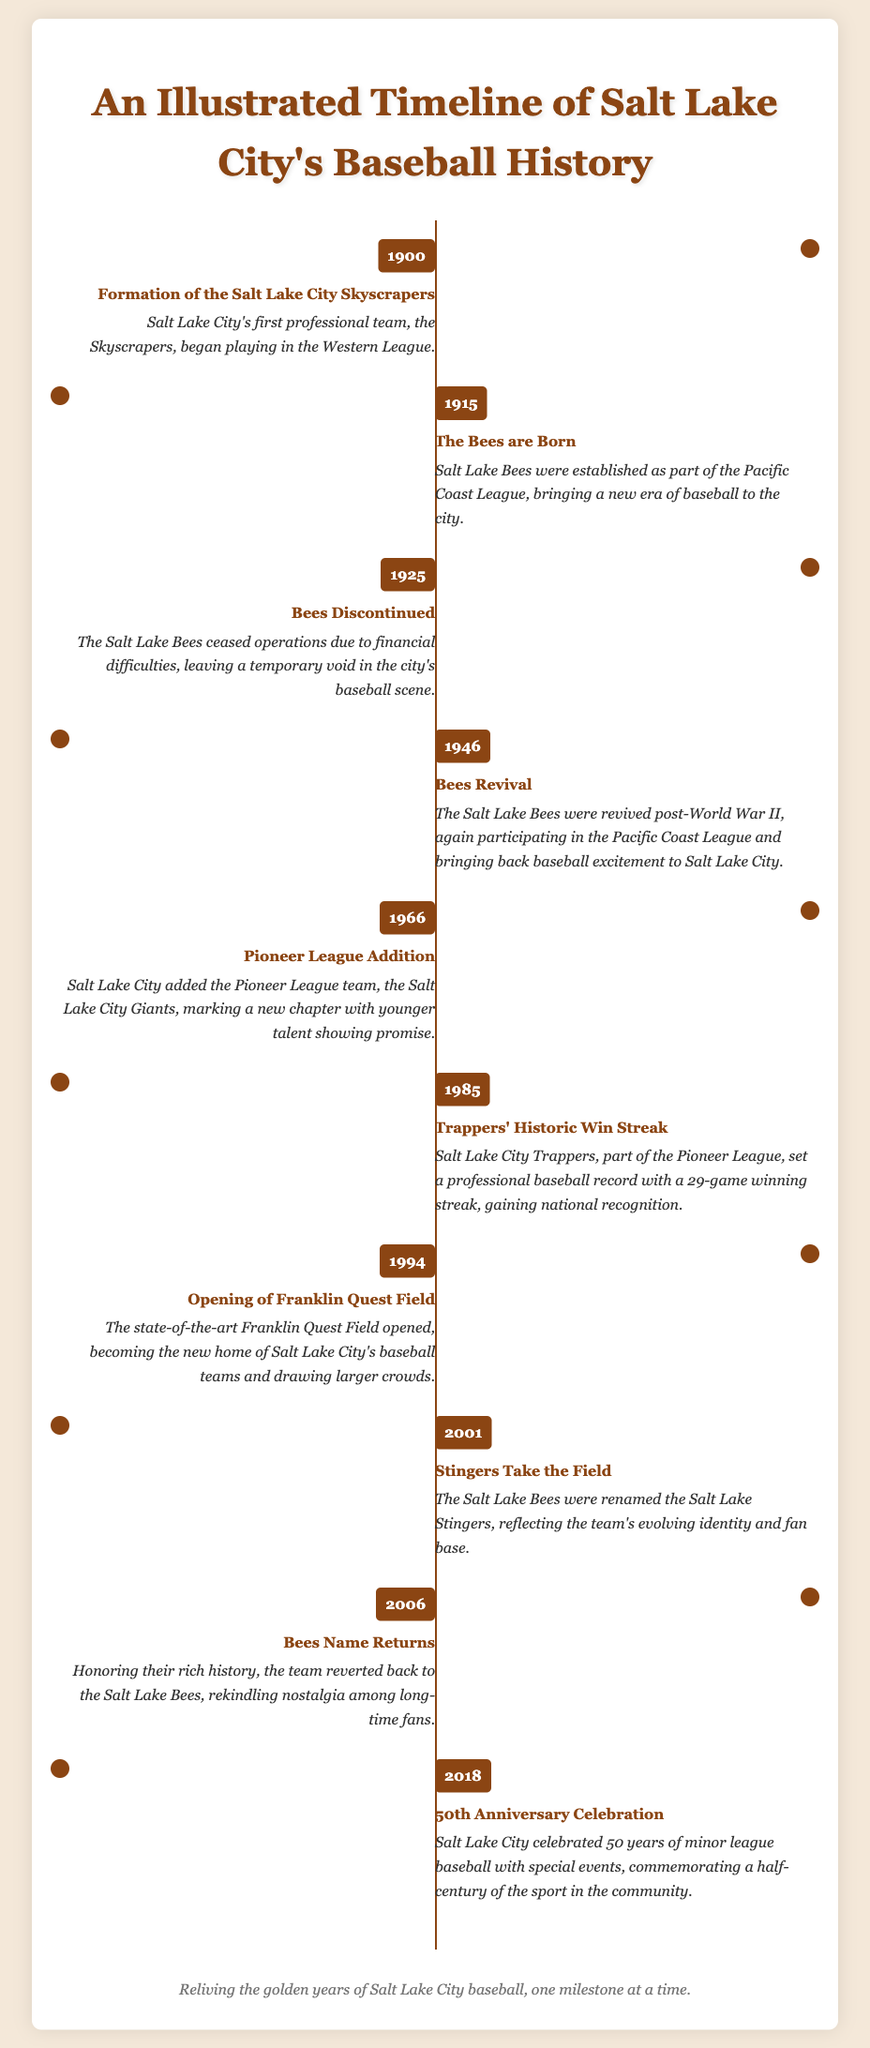What year was the Salt Lake City Skyscrapers formed? The document states that the Salt Lake City Skyscrapers were formed in the year 1900.
Answer: 1900 What event occurred in Salt Lake City in 1915? According to the document, the establishment of the Salt Lake Bees occurred in 1915.
Answer: The Bees are Born When did the Salt Lake Bees cease operations? The document mentions that the Salt Lake Bees discontinued in 1925.
Answer: 1925 How many games did the Salt Lake City Trappers win in their historic streak? The document notes that the Salt Lake City Trappers set a record with a 29-game winning streak.
Answer: 29-game winning streak What was the name of the ballpark opened in 1994? The timeline states that the ballpark opened in 1994 was Franklin Quest Field.
Answer: Franklin Quest Field Which team name did the Bees adopt in 2001? According to the document, in 2001, the Bees were renamed Salt Lake Stingers.
Answer: Salt Lake Stingers How many years of minor-league baseball were celebrated in 2018? The document indicates that the celebration in 2018 marked the 50th anniversary of minor league baseball.
Answer: 50 years What was the notable achievement of the Salt Lake City Trappers in 1985? The document highlights that the Trappers set a professional baseball record with a 29-game winning streak in 1985.
Answer: Historic Win Streak What did the Bees revert back to in 2006? The document states that in 2006, the team reverted back to the Salt Lake Bees.
Answer: Salt Lake Bees 